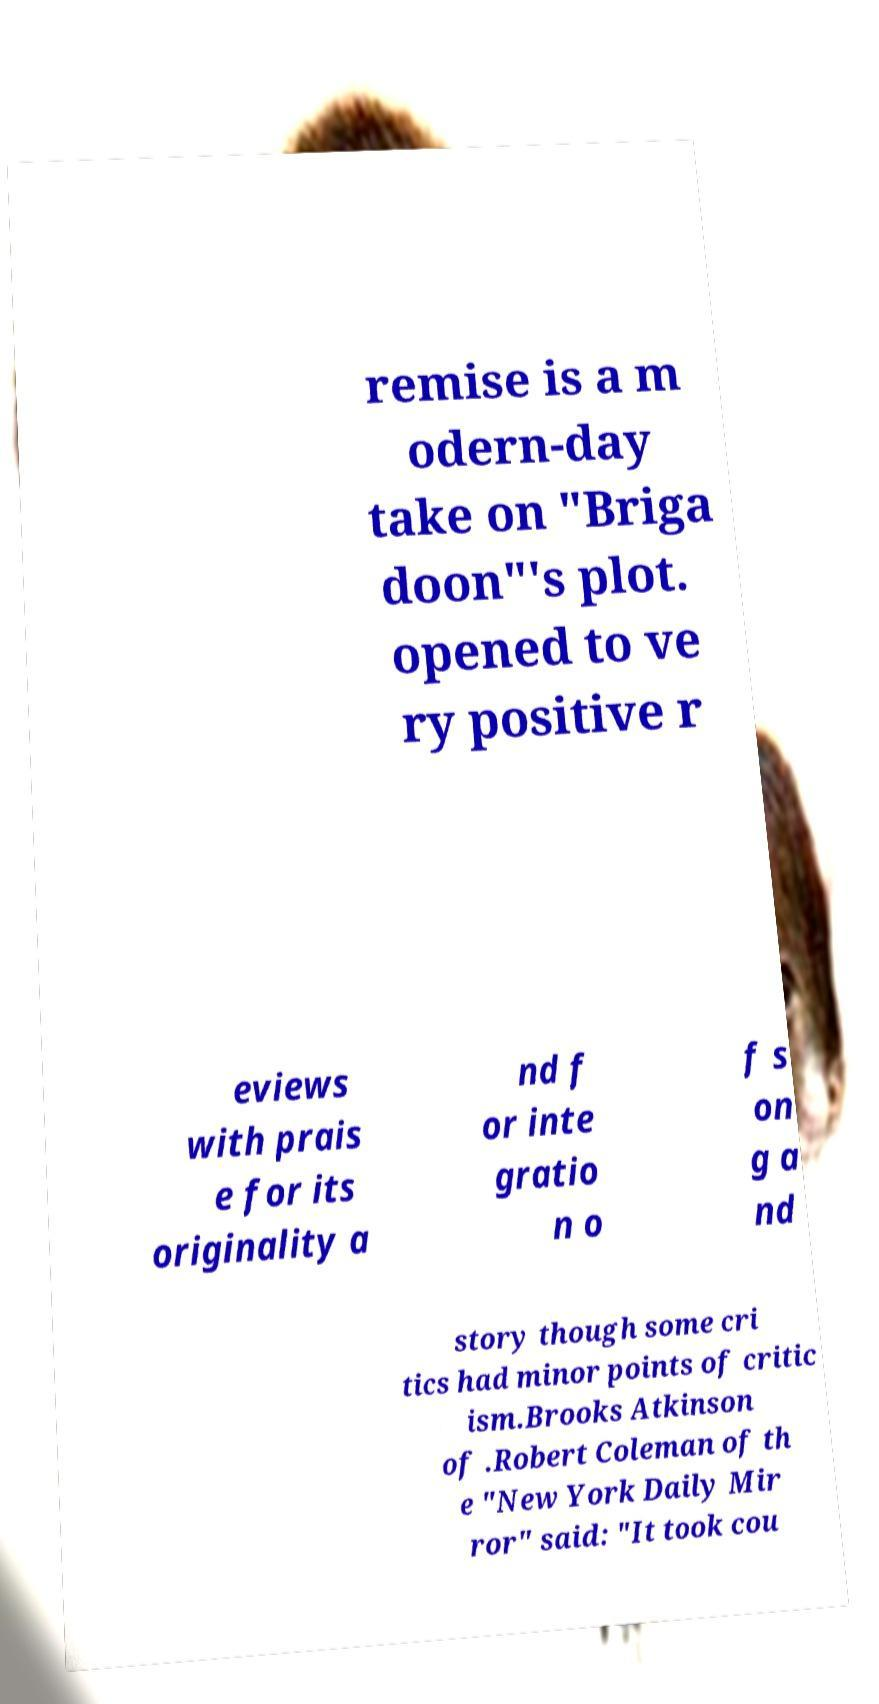Could you assist in decoding the text presented in this image and type it out clearly? remise is a m odern-day take on "Briga doon"'s plot. opened to ve ry positive r eviews with prais e for its originality a nd f or inte gratio n o f s on g a nd story though some cri tics had minor points of critic ism.Brooks Atkinson of .Robert Coleman of th e "New York Daily Mir ror" said: "It took cou 